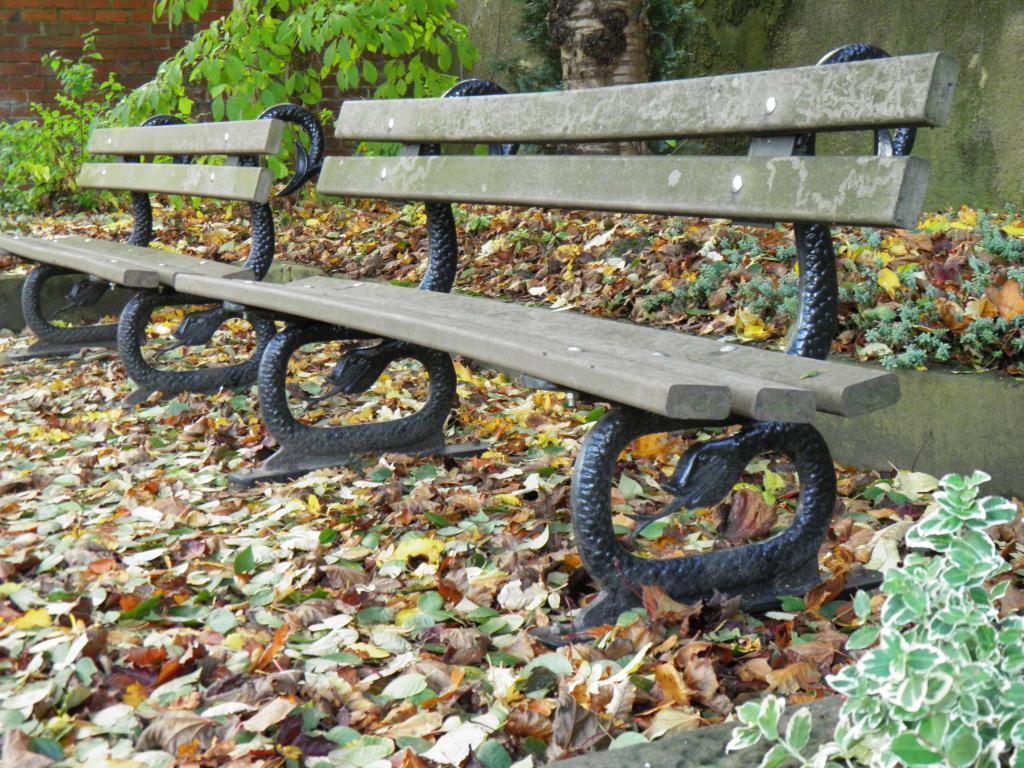Could you give a brief overview of what you see in this image? In this image I can see the benches on the ground. In the background, I can see the wall and the plants. 